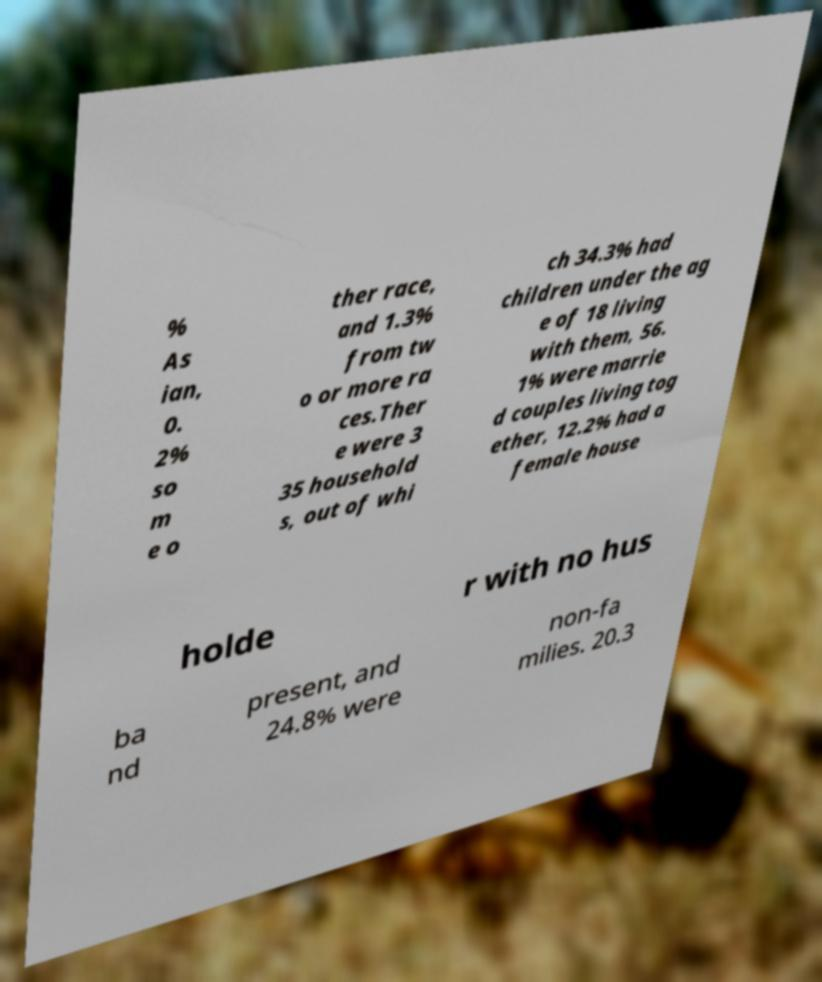For documentation purposes, I need the text within this image transcribed. Could you provide that? % As ian, 0. 2% so m e o ther race, and 1.3% from tw o or more ra ces.Ther e were 3 35 household s, out of whi ch 34.3% had children under the ag e of 18 living with them, 56. 1% were marrie d couples living tog ether, 12.2% had a female house holde r with no hus ba nd present, and 24.8% were non-fa milies. 20.3 